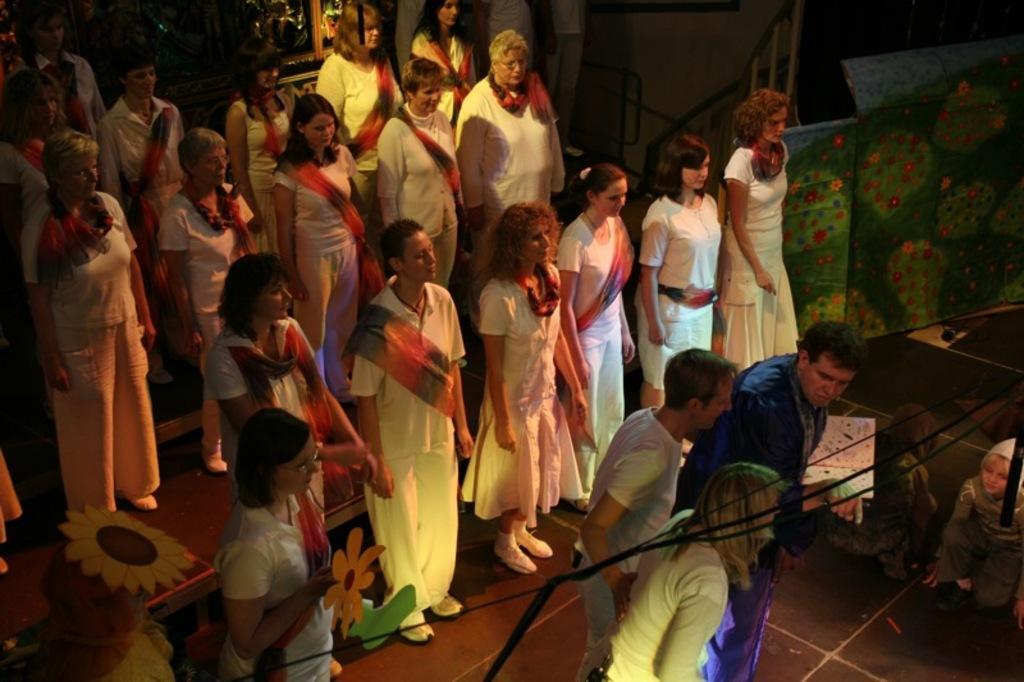Describe this image in one or two sentences. In the picture I can see a group of people standing on the floor. They are wearing a white color dress. There is a man on the bottom right side and he is holding a book. I can see two children on the floor on the bottom right side. 